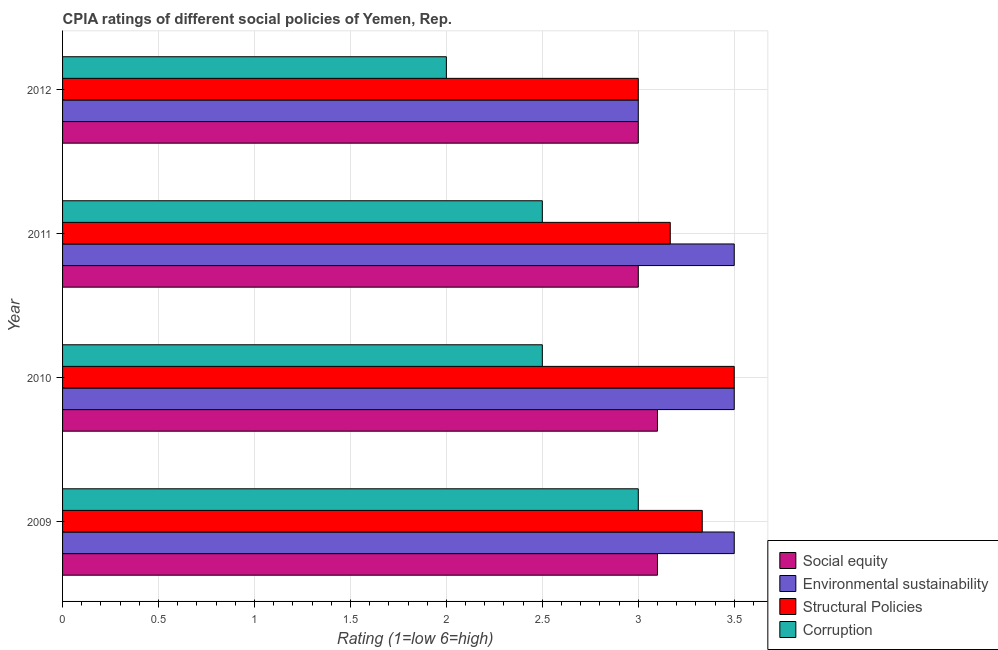How many different coloured bars are there?
Provide a short and direct response. 4. Are the number of bars per tick equal to the number of legend labels?
Ensure brevity in your answer.  Yes. Are the number of bars on each tick of the Y-axis equal?
Your response must be concise. Yes. What is the label of the 3rd group of bars from the top?
Offer a very short reply. 2010. In how many cases, is the number of bars for a given year not equal to the number of legend labels?
Your answer should be very brief. 0. In which year was the cpia rating of social equity maximum?
Give a very brief answer. 2009. What is the difference between the cpia rating of structural policies in 2009 and that in 2010?
Your response must be concise. -0.17. What is the difference between the cpia rating of corruption in 2009 and the cpia rating of environmental sustainability in 2012?
Make the answer very short. 0. What is the average cpia rating of social equity per year?
Offer a very short reply. 3.05. In how many years, is the cpia rating of environmental sustainability greater than 2.9 ?
Provide a short and direct response. 4. What is the difference between the highest and the second highest cpia rating of environmental sustainability?
Make the answer very short. 0. Is it the case that in every year, the sum of the cpia rating of structural policies and cpia rating of social equity is greater than the sum of cpia rating of corruption and cpia rating of environmental sustainability?
Your answer should be very brief. Yes. What does the 2nd bar from the top in 2011 represents?
Give a very brief answer. Structural Policies. What does the 2nd bar from the bottom in 2011 represents?
Offer a very short reply. Environmental sustainability. Is it the case that in every year, the sum of the cpia rating of social equity and cpia rating of environmental sustainability is greater than the cpia rating of structural policies?
Offer a terse response. Yes. Does the graph contain any zero values?
Keep it short and to the point. No. Does the graph contain grids?
Your answer should be compact. Yes. Where does the legend appear in the graph?
Ensure brevity in your answer.  Bottom right. What is the title of the graph?
Offer a very short reply. CPIA ratings of different social policies of Yemen, Rep. Does "Compensation of employees" appear as one of the legend labels in the graph?
Offer a terse response. No. What is the Rating (1=low 6=high) in Environmental sustainability in 2009?
Offer a terse response. 3.5. What is the Rating (1=low 6=high) in Structural Policies in 2009?
Make the answer very short. 3.33. What is the Rating (1=low 6=high) of Structural Policies in 2010?
Your response must be concise. 3.5. What is the Rating (1=low 6=high) of Environmental sustainability in 2011?
Provide a short and direct response. 3.5. What is the Rating (1=low 6=high) of Structural Policies in 2011?
Give a very brief answer. 3.17. What is the Rating (1=low 6=high) of Corruption in 2011?
Make the answer very short. 2.5. What is the Rating (1=low 6=high) in Environmental sustainability in 2012?
Make the answer very short. 3. What is the Rating (1=low 6=high) in Structural Policies in 2012?
Your answer should be very brief. 3. Across all years, what is the maximum Rating (1=low 6=high) of Social equity?
Keep it short and to the point. 3.1. Across all years, what is the maximum Rating (1=low 6=high) of Corruption?
Your answer should be compact. 3. Across all years, what is the minimum Rating (1=low 6=high) of Social equity?
Provide a succinct answer. 3. Across all years, what is the minimum Rating (1=low 6=high) of Environmental sustainability?
Your answer should be compact. 3. Across all years, what is the minimum Rating (1=low 6=high) of Structural Policies?
Offer a terse response. 3. Across all years, what is the minimum Rating (1=low 6=high) in Corruption?
Keep it short and to the point. 2. What is the total Rating (1=low 6=high) of Social equity in the graph?
Offer a very short reply. 12.2. What is the total Rating (1=low 6=high) in Corruption in the graph?
Your response must be concise. 10. What is the difference between the Rating (1=low 6=high) of Environmental sustainability in 2009 and that in 2010?
Offer a terse response. 0. What is the difference between the Rating (1=low 6=high) of Structural Policies in 2009 and that in 2010?
Ensure brevity in your answer.  -0.17. What is the difference between the Rating (1=low 6=high) in Corruption in 2009 and that in 2010?
Your answer should be compact. 0.5. What is the difference between the Rating (1=low 6=high) in Social equity in 2009 and that in 2011?
Keep it short and to the point. 0.1. What is the difference between the Rating (1=low 6=high) of Environmental sustainability in 2009 and that in 2011?
Provide a short and direct response. 0. What is the difference between the Rating (1=low 6=high) in Structural Policies in 2009 and that in 2011?
Provide a succinct answer. 0.17. What is the difference between the Rating (1=low 6=high) in Environmental sustainability in 2009 and that in 2012?
Provide a succinct answer. 0.5. What is the difference between the Rating (1=low 6=high) of Social equity in 2010 and that in 2011?
Provide a short and direct response. 0.1. What is the difference between the Rating (1=low 6=high) of Environmental sustainability in 2010 and that in 2011?
Provide a short and direct response. 0. What is the difference between the Rating (1=low 6=high) in Structural Policies in 2010 and that in 2011?
Provide a short and direct response. 0.33. What is the difference between the Rating (1=low 6=high) of Social equity in 2011 and that in 2012?
Your answer should be very brief. 0. What is the difference between the Rating (1=low 6=high) in Corruption in 2011 and that in 2012?
Your answer should be very brief. 0.5. What is the difference between the Rating (1=low 6=high) of Social equity in 2009 and the Rating (1=low 6=high) of Corruption in 2010?
Offer a terse response. 0.6. What is the difference between the Rating (1=low 6=high) of Social equity in 2009 and the Rating (1=low 6=high) of Structural Policies in 2011?
Make the answer very short. -0.07. What is the difference between the Rating (1=low 6=high) of Environmental sustainability in 2009 and the Rating (1=low 6=high) of Structural Policies in 2011?
Ensure brevity in your answer.  0.33. What is the difference between the Rating (1=low 6=high) in Environmental sustainability in 2009 and the Rating (1=low 6=high) in Corruption in 2011?
Keep it short and to the point. 1. What is the difference between the Rating (1=low 6=high) of Social equity in 2009 and the Rating (1=low 6=high) of Environmental sustainability in 2012?
Offer a terse response. 0.1. What is the difference between the Rating (1=low 6=high) in Social equity in 2010 and the Rating (1=low 6=high) in Environmental sustainability in 2011?
Offer a terse response. -0.4. What is the difference between the Rating (1=low 6=high) in Social equity in 2010 and the Rating (1=low 6=high) in Structural Policies in 2011?
Your response must be concise. -0.07. What is the difference between the Rating (1=low 6=high) in Environmental sustainability in 2010 and the Rating (1=low 6=high) in Structural Policies in 2011?
Give a very brief answer. 0.33. What is the difference between the Rating (1=low 6=high) in Social equity in 2010 and the Rating (1=low 6=high) in Environmental sustainability in 2012?
Offer a very short reply. 0.1. What is the difference between the Rating (1=low 6=high) in Structural Policies in 2010 and the Rating (1=low 6=high) in Corruption in 2012?
Your answer should be very brief. 1.5. What is the difference between the Rating (1=low 6=high) in Social equity in 2011 and the Rating (1=low 6=high) in Environmental sustainability in 2012?
Ensure brevity in your answer.  0. What is the difference between the Rating (1=low 6=high) of Social equity in 2011 and the Rating (1=low 6=high) of Structural Policies in 2012?
Provide a succinct answer. 0. What is the difference between the Rating (1=low 6=high) of Environmental sustainability in 2011 and the Rating (1=low 6=high) of Corruption in 2012?
Provide a succinct answer. 1.5. What is the average Rating (1=low 6=high) in Social equity per year?
Ensure brevity in your answer.  3.05. What is the average Rating (1=low 6=high) in Environmental sustainability per year?
Your response must be concise. 3.38. What is the average Rating (1=low 6=high) of Structural Policies per year?
Your answer should be compact. 3.25. What is the average Rating (1=low 6=high) of Corruption per year?
Provide a succinct answer. 2.5. In the year 2009, what is the difference between the Rating (1=low 6=high) of Social equity and Rating (1=low 6=high) of Structural Policies?
Your answer should be very brief. -0.23. In the year 2009, what is the difference between the Rating (1=low 6=high) of Environmental sustainability and Rating (1=low 6=high) of Structural Policies?
Your answer should be very brief. 0.17. In the year 2010, what is the difference between the Rating (1=low 6=high) of Social equity and Rating (1=low 6=high) of Structural Policies?
Offer a very short reply. -0.4. In the year 2010, what is the difference between the Rating (1=low 6=high) of Social equity and Rating (1=low 6=high) of Corruption?
Your answer should be very brief. 0.6. In the year 2010, what is the difference between the Rating (1=low 6=high) of Environmental sustainability and Rating (1=low 6=high) of Structural Policies?
Keep it short and to the point. 0. In the year 2010, what is the difference between the Rating (1=low 6=high) in Environmental sustainability and Rating (1=low 6=high) in Corruption?
Your response must be concise. 1. In the year 2010, what is the difference between the Rating (1=low 6=high) in Structural Policies and Rating (1=low 6=high) in Corruption?
Provide a succinct answer. 1. In the year 2011, what is the difference between the Rating (1=low 6=high) of Social equity and Rating (1=low 6=high) of Structural Policies?
Make the answer very short. -0.17. In the year 2011, what is the difference between the Rating (1=low 6=high) of Environmental sustainability and Rating (1=low 6=high) of Corruption?
Your answer should be compact. 1. In the year 2012, what is the difference between the Rating (1=low 6=high) in Social equity and Rating (1=low 6=high) in Structural Policies?
Keep it short and to the point. 0. In the year 2012, what is the difference between the Rating (1=low 6=high) in Environmental sustainability and Rating (1=low 6=high) in Corruption?
Ensure brevity in your answer.  1. In the year 2012, what is the difference between the Rating (1=low 6=high) in Structural Policies and Rating (1=low 6=high) in Corruption?
Offer a very short reply. 1. What is the ratio of the Rating (1=low 6=high) of Social equity in 2009 to that in 2010?
Your response must be concise. 1. What is the ratio of the Rating (1=low 6=high) of Environmental sustainability in 2009 to that in 2010?
Provide a short and direct response. 1. What is the ratio of the Rating (1=low 6=high) in Structural Policies in 2009 to that in 2010?
Give a very brief answer. 0.95. What is the ratio of the Rating (1=low 6=high) of Environmental sustainability in 2009 to that in 2011?
Keep it short and to the point. 1. What is the ratio of the Rating (1=low 6=high) of Structural Policies in 2009 to that in 2011?
Provide a short and direct response. 1.05. What is the ratio of the Rating (1=low 6=high) of Corruption in 2009 to that in 2011?
Give a very brief answer. 1.2. What is the ratio of the Rating (1=low 6=high) of Social equity in 2009 to that in 2012?
Your answer should be compact. 1.03. What is the ratio of the Rating (1=low 6=high) in Structural Policies in 2009 to that in 2012?
Your answer should be very brief. 1.11. What is the ratio of the Rating (1=low 6=high) of Corruption in 2009 to that in 2012?
Your response must be concise. 1.5. What is the ratio of the Rating (1=low 6=high) in Environmental sustainability in 2010 to that in 2011?
Your answer should be very brief. 1. What is the ratio of the Rating (1=low 6=high) in Structural Policies in 2010 to that in 2011?
Make the answer very short. 1.11. What is the ratio of the Rating (1=low 6=high) of Environmental sustainability in 2010 to that in 2012?
Offer a very short reply. 1.17. What is the ratio of the Rating (1=low 6=high) of Structural Policies in 2010 to that in 2012?
Keep it short and to the point. 1.17. What is the ratio of the Rating (1=low 6=high) in Social equity in 2011 to that in 2012?
Keep it short and to the point. 1. What is the ratio of the Rating (1=low 6=high) of Environmental sustainability in 2011 to that in 2012?
Ensure brevity in your answer.  1.17. What is the ratio of the Rating (1=low 6=high) in Structural Policies in 2011 to that in 2012?
Offer a very short reply. 1.06. What is the ratio of the Rating (1=low 6=high) in Corruption in 2011 to that in 2012?
Your answer should be compact. 1.25. What is the difference between the highest and the second highest Rating (1=low 6=high) of Structural Policies?
Provide a succinct answer. 0.17. What is the difference between the highest and the second highest Rating (1=low 6=high) in Corruption?
Make the answer very short. 0.5. What is the difference between the highest and the lowest Rating (1=low 6=high) in Environmental sustainability?
Give a very brief answer. 0.5. What is the difference between the highest and the lowest Rating (1=low 6=high) in Structural Policies?
Keep it short and to the point. 0.5. What is the difference between the highest and the lowest Rating (1=low 6=high) of Corruption?
Make the answer very short. 1. 